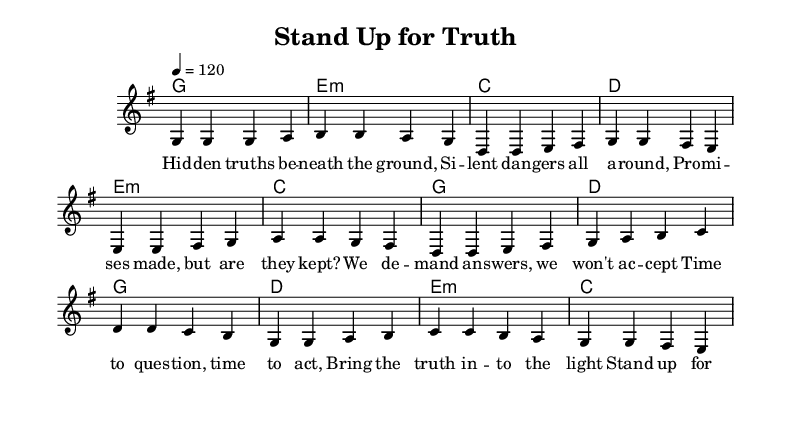What is the key signature of this music? The key signature is G major, which has one sharp (F#). This can be identified in the left-hand corner of the sheet music where the key signature is displayed.
Answer: G major What is the time signature of this piece? The time signature is 4/4, indicating there are four beats per measure and the quarter note receives one beat. This is shown at the beginning of the staff.
Answer: 4/4 What is the tempo marking for the piece? The tempo marking is 120 beats per minute, indicated by the tempo notation in the score which specifies the speed of the music.
Answer: 120 How many measures are in the verse section of the song? The verse section consists of four measures, as counted by the groupings of notes separated by vertical lines (bar lines) in the melody part.
Answer: Four measures What is the first note in the melody? The first note in the melody of the piece is G, which can be found at the beginning of the melody line in the staff.
Answer: G What is the main theme of the lyrics? The main theme of the lyrics addresses social injustice and the demand for truth, which is reflected in phrases like "Stand up for truth" and "No more secrets." This can be inferred from the lyrical content in the score.
Answer: Social injustice 